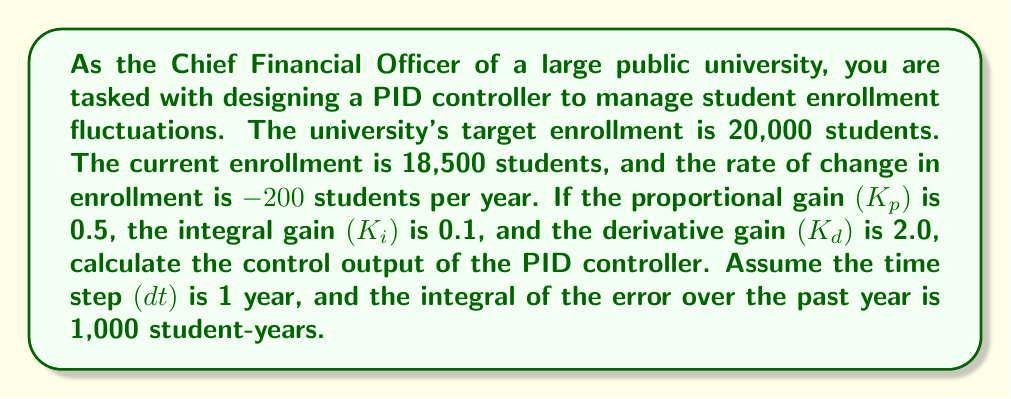Show me your answer to this math problem. To solve this problem, we need to use the PID controller equation:

$$u(t) = K_p e(t) + K_i \int_0^t e(\tau) d\tau + K_d \frac{de(t)}{dt}$$

Where:
- $u(t)$ is the control output
- $e(t)$ is the error (difference between target and current value)
- $K_p$, $K_i$, and $K_d$ are the proportional, integral, and derivative gains respectively

Let's break down the problem and calculate each component:

1. Error calculation:
   $e(t) = \text{Target} - \text{Current}$
   $e(t) = 20,000 - 18,500 = 1,500$ students

2. Proportional term:
   $K_p e(t) = 0.5 \times 1,500 = 750$

3. Integral term:
   $K_i \int_0^t e(\tau) d\tau = 0.1 \times 1,000 = 100$

4. Derivative term:
   $K_d \frac{de(t)}{dt} = 2.0 \times (-200) = -400$

Now, we sum up all three terms to get the control output:

$$u(t) = 750 + 100 + (-400) = 450$$
Answer: The control output of the PID controller is 450 students. 